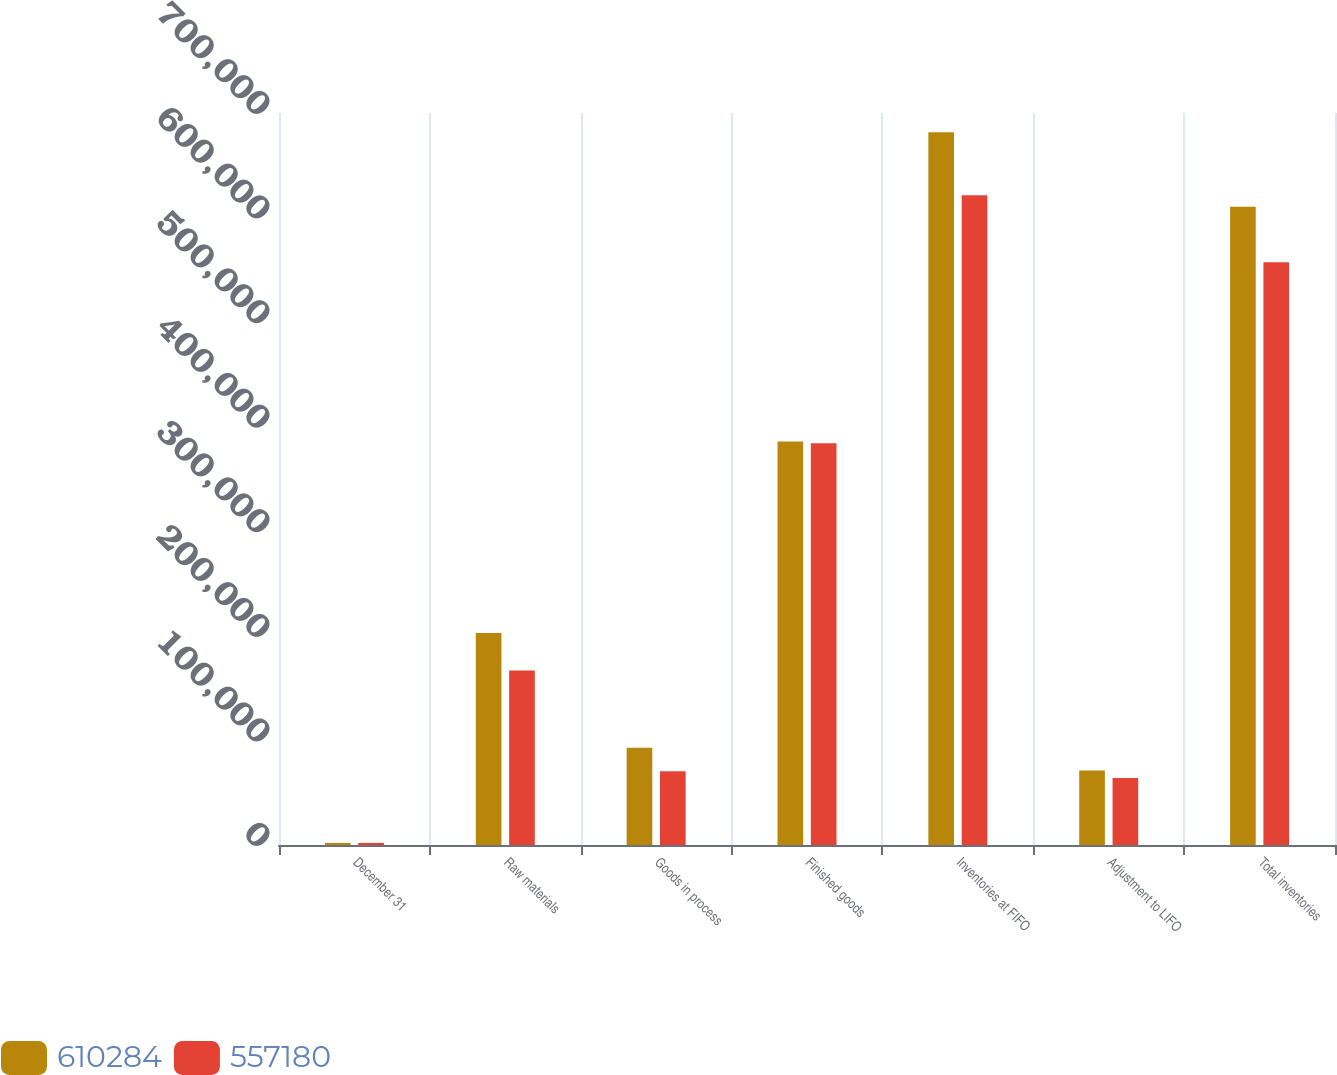<chart> <loc_0><loc_0><loc_500><loc_500><stacked_bar_chart><ecel><fcel>December 31<fcel>Raw materials<fcel>Goods in process<fcel>Finished goods<fcel>Inventories at FIFO<fcel>Adjustment to LIFO<fcel>Total inventories<nl><fcel>610284<fcel>2005<fcel>202826<fcel>92923<fcel>385798<fcel>681547<fcel>71263<fcel>610284<nl><fcel>557180<fcel>2004<fcel>166813<fcel>70440<fcel>384094<fcel>621347<fcel>64167<fcel>557180<nl></chart> 